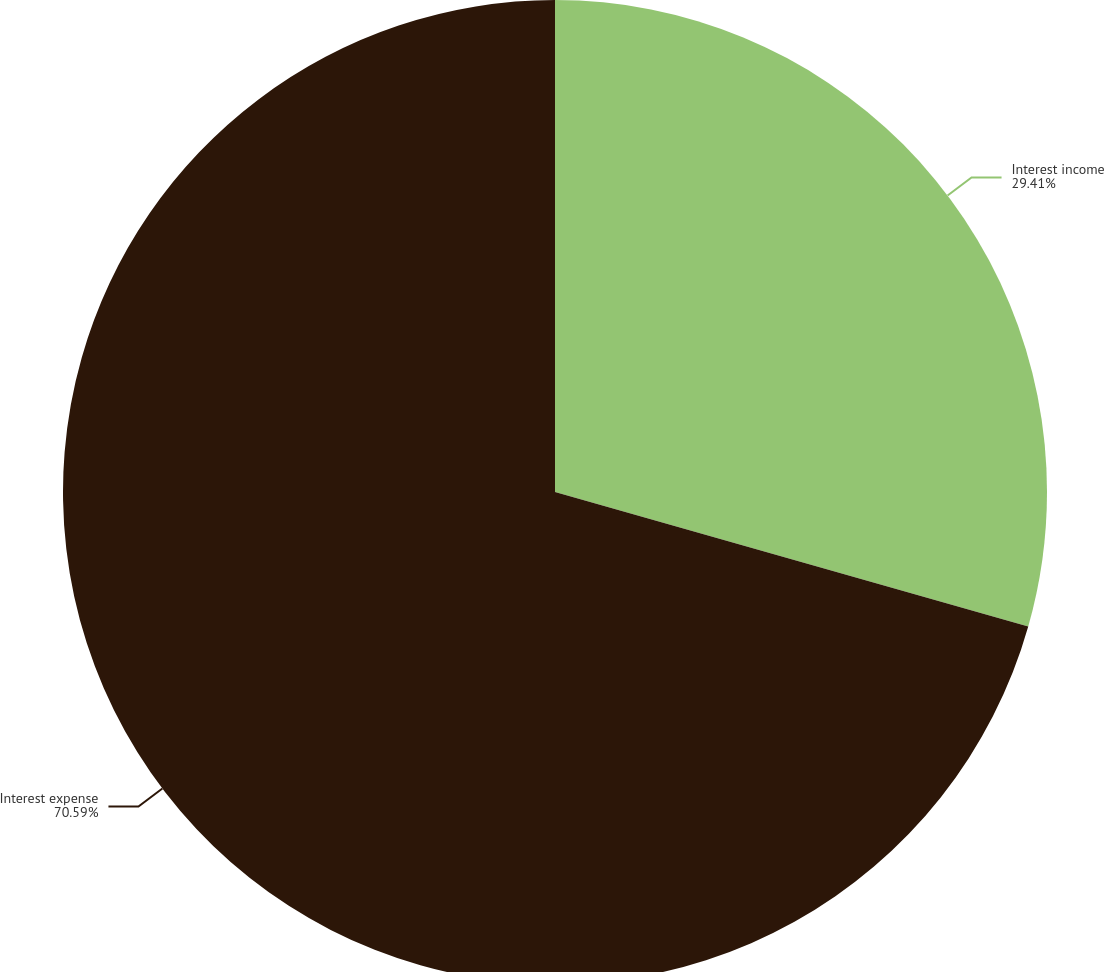Convert chart to OTSL. <chart><loc_0><loc_0><loc_500><loc_500><pie_chart><fcel>Interest income<fcel>Interest expense<nl><fcel>29.41%<fcel>70.59%<nl></chart> 